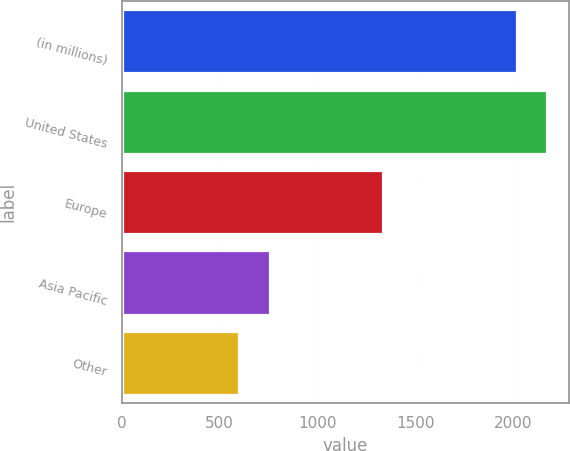<chart> <loc_0><loc_0><loc_500><loc_500><bar_chart><fcel>(in millions)<fcel>United States<fcel>Europe<fcel>Asia Pacific<fcel>Other<nl><fcel>2017<fcel>2173.1<fcel>1335<fcel>756.1<fcel>600<nl></chart> 